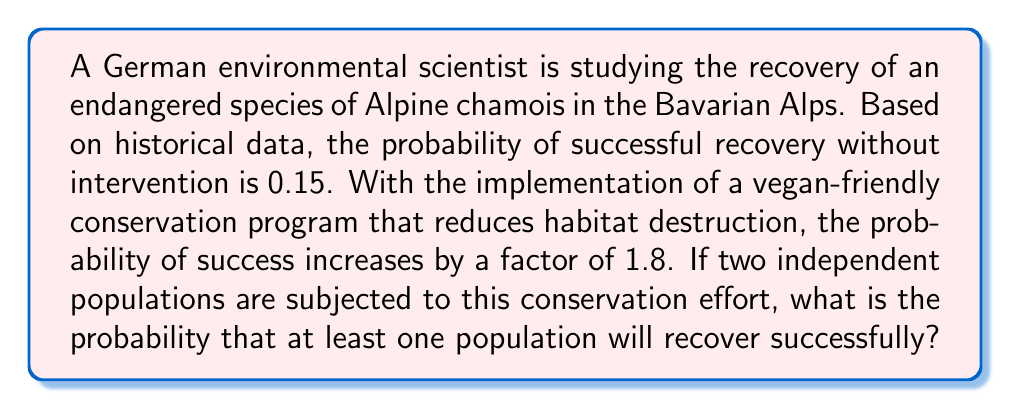Can you solve this math problem? Let's approach this step-by-step:

1) First, we need to calculate the probability of successful recovery with the conservation program:
   $P(\text{success with program}) = 0.15 \times 1.8 = 0.27$

2) Now, we need to find the probability that at least one of the two populations recovers. It's easier to calculate the probability that neither population recovers and then subtract this from 1.

3) The probability that a single population doesn't recover with the program is:
   $P(\text{failure for one population}) = 1 - 0.27 = 0.73$

4) For both populations to fail, we multiply these probabilities (since the populations are independent):
   $P(\text{both fail}) = 0.73 \times 0.73 = 0.5329$

5) Therefore, the probability that at least one population recovers is:
   $P(\text{at least one recovers}) = 1 - P(\text{both fail}) = 1 - 0.5329 = 0.4671$

6) We can express this as a percentage: $0.4671 \times 100\% = 46.71\%$
Answer: 46.71% 